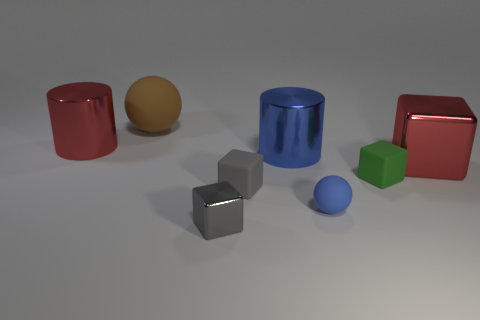Subtract all green cubes. How many cubes are left? 3 Subtract all cyan balls. How many gray cubes are left? 2 Add 1 big brown matte balls. How many objects exist? 9 Subtract all red blocks. How many blocks are left? 3 Subtract all blue cubes. Subtract all blue balls. How many cubes are left? 4 Subtract all cylinders. How many objects are left? 6 Subtract 1 gray cubes. How many objects are left? 7 Subtract all large purple cylinders. Subtract all green objects. How many objects are left? 7 Add 5 large shiny cubes. How many large shiny cubes are left? 6 Add 7 yellow shiny spheres. How many yellow shiny spheres exist? 7 